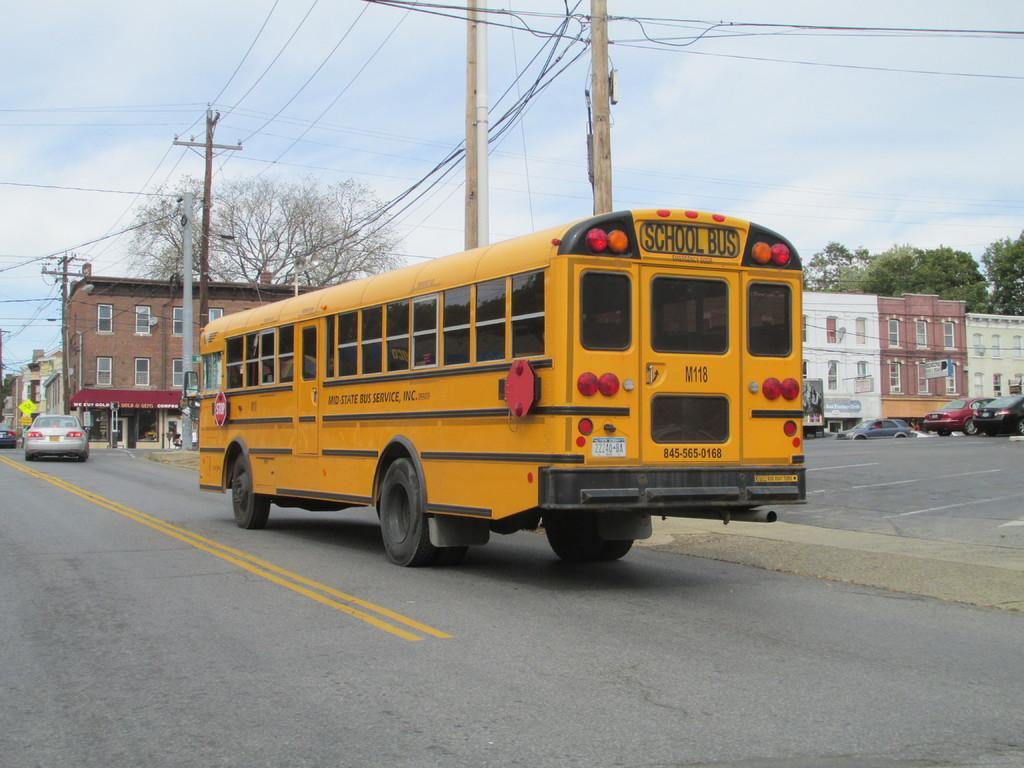Could you give a brief overview of what you see in this image? Here we can see a bus on the road. In the background there are vehicles on the road,electric poles,wires,buildings,windows,hoardings,trees and clouds in the sky. 